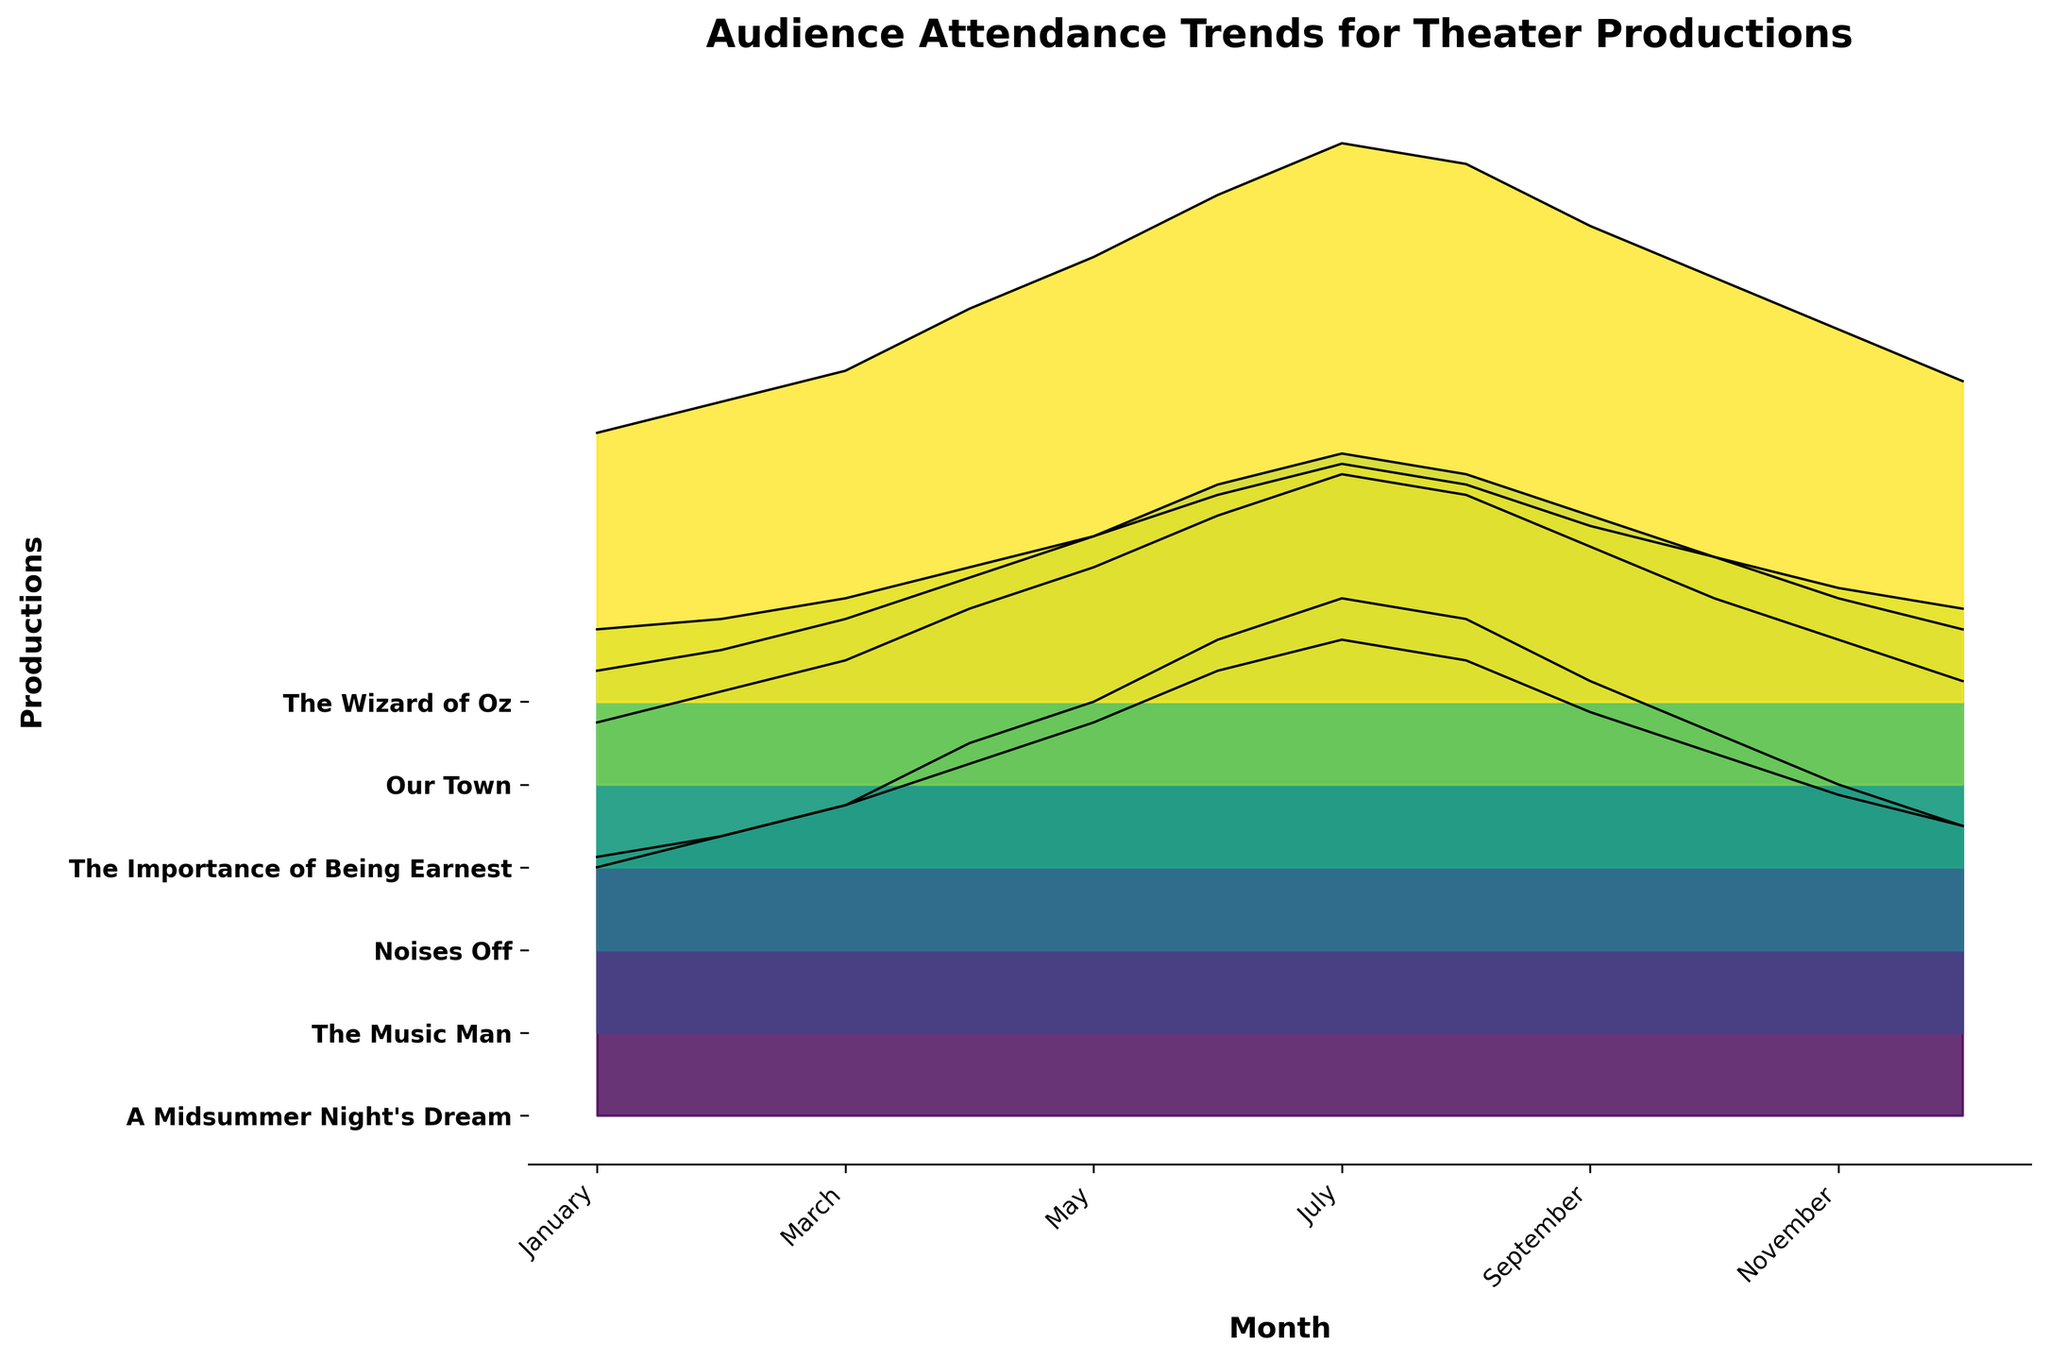What is the title of the plot? The title is located at the top of the plot and provides an overview of the data being represented. It reads "Audience Attendance Trends for Theater Productions".
Answer: Audience Attendance Trends for Theater Productions How many theater productions are represented in the plot? We can count the number of y-ticks labels to determine the number of theater productions. There are 6 labels corresponding to different productions: "A Midsummer Night's Dream", "The Music Man", "Noises Off", "The Importance of Being Earnest", "Our Town", and "The Wizard of Oz".
Answer: 6 During which month does "The Wizard of Oz" have the highest audience attendance? By tracing the filled curves, we see that the peak for "The Wizard of Oz", marked by the highest point of the curve, is in July.
Answer: July Which production has the lowest audience attendance in November? Look at the y-ticks on the left, locate November on the x-axis, and compare the heights of the curves. "Our Town" has the lowest filled area in November.
Answer: Our Town What is the overall trend in audience attendance across all productions from January to December? Observing the general direction of the curves from left to right, we see that most productions have rising attendance from January to around summer (June/July) and then a decline towards December.
Answer: Increase and then decrease Which production sees the most significant drop in attendance from August to September? Comparing the height difference between August and September for each production, "The Wizard of Oz" shows the most substantial decrease.
Answer: The Wizard of Oz What is the average attendance for "A Midsummer Night's Dream" over the whole year? Calculate the mean by summing the attendance for each month and dividing by 12: (120 + 135 + 150 + 180 + 200 + 230 + 250 + 240 + 210 + 185 + 160 + 140) / 12 = 205
Answer: 205 Which months show the highest variance in attendance among all productions? By looking at the y-axis ranges for each month, months like June, July, and August show a wider spread among the productions, indicating high variance.
Answer: June, July, and August Between "The Music Man" and "Noises Off", which production has higher attendance in March? Trace the curves for March and compare the filled areas or peaks. "Noises Off" has a higher filled area than "The Music Man" in March.
Answer: Noises Off 